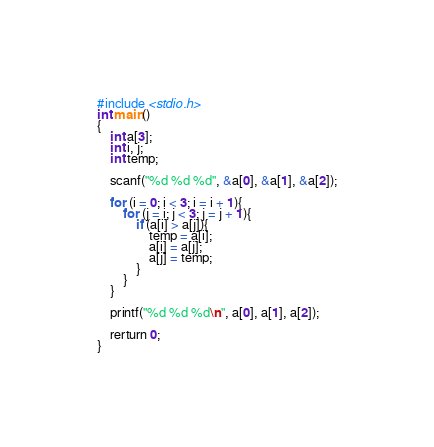<code> <loc_0><loc_0><loc_500><loc_500><_C_>#include <stdio.h>
int main()
{
    int a[3];
    int i, j;
    int temp;
     
    scanf("%d %d %d", &a[0], &a[1], &a[2]);
     
    for (i = 0; i < 3; i = i + 1){
        for (j = i; j < 3; j = j + 1){
            if (a[i] > a[j]){
                temp = a[i];
                a[i] = a[j];
                a[j] = temp;
            }
        }
    }
     
    printf("%d %d %d\n", a[0], a[1], a[2]);
     
    rerturn 0;
}</code> 